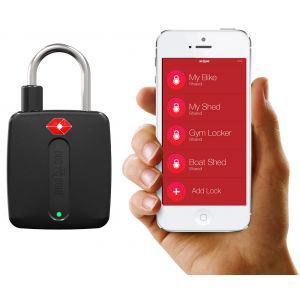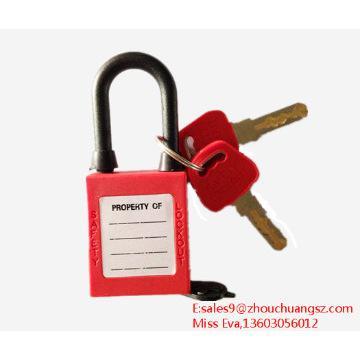The first image is the image on the left, the second image is the image on the right. Examine the images to the left and right. Is the description "One of the locks on the left is black." accurate? Answer yes or no. Yes. 